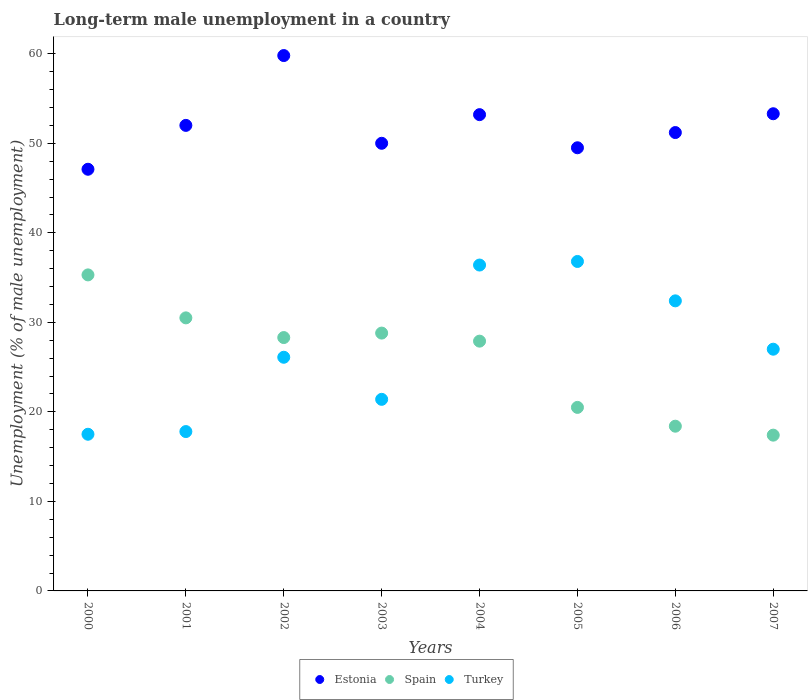Is the number of dotlines equal to the number of legend labels?
Your answer should be very brief. Yes. Across all years, what is the maximum percentage of long-term unemployed male population in Turkey?
Provide a succinct answer. 36.8. Across all years, what is the minimum percentage of long-term unemployed male population in Spain?
Keep it short and to the point. 17.4. What is the total percentage of long-term unemployed male population in Spain in the graph?
Offer a terse response. 207.1. What is the difference between the percentage of long-term unemployed male population in Estonia in 2002 and that in 2004?
Provide a short and direct response. 6.6. What is the difference between the percentage of long-term unemployed male population in Turkey in 2003 and the percentage of long-term unemployed male population in Spain in 2001?
Your answer should be compact. -9.1. What is the average percentage of long-term unemployed male population in Turkey per year?
Provide a succinct answer. 26.93. In the year 2004, what is the difference between the percentage of long-term unemployed male population in Estonia and percentage of long-term unemployed male population in Turkey?
Provide a succinct answer. 16.8. What is the ratio of the percentage of long-term unemployed male population in Turkey in 2002 to that in 2003?
Provide a short and direct response. 1.22. Is the percentage of long-term unemployed male population in Spain in 2000 less than that in 2007?
Your answer should be very brief. No. What is the difference between the highest and the second highest percentage of long-term unemployed male population in Spain?
Provide a short and direct response. 4.8. What is the difference between the highest and the lowest percentage of long-term unemployed male population in Spain?
Your answer should be compact. 17.9. Is the sum of the percentage of long-term unemployed male population in Turkey in 2005 and 2007 greater than the maximum percentage of long-term unemployed male population in Estonia across all years?
Your answer should be compact. Yes. Is the percentage of long-term unemployed male population in Estonia strictly greater than the percentage of long-term unemployed male population in Spain over the years?
Offer a very short reply. Yes. Is the percentage of long-term unemployed male population in Turkey strictly less than the percentage of long-term unemployed male population in Estonia over the years?
Keep it short and to the point. Yes. What is the difference between two consecutive major ticks on the Y-axis?
Make the answer very short. 10. Are the values on the major ticks of Y-axis written in scientific E-notation?
Make the answer very short. No. Does the graph contain grids?
Keep it short and to the point. No. Where does the legend appear in the graph?
Ensure brevity in your answer.  Bottom center. How are the legend labels stacked?
Ensure brevity in your answer.  Horizontal. What is the title of the graph?
Make the answer very short. Long-term male unemployment in a country. Does "Bulgaria" appear as one of the legend labels in the graph?
Your answer should be very brief. No. What is the label or title of the Y-axis?
Offer a terse response. Unemployment (% of male unemployment). What is the Unemployment (% of male unemployment) in Estonia in 2000?
Offer a very short reply. 47.1. What is the Unemployment (% of male unemployment) in Spain in 2000?
Give a very brief answer. 35.3. What is the Unemployment (% of male unemployment) in Estonia in 2001?
Your answer should be compact. 52. What is the Unemployment (% of male unemployment) of Spain in 2001?
Make the answer very short. 30.5. What is the Unemployment (% of male unemployment) in Turkey in 2001?
Ensure brevity in your answer.  17.8. What is the Unemployment (% of male unemployment) of Estonia in 2002?
Make the answer very short. 59.8. What is the Unemployment (% of male unemployment) of Spain in 2002?
Provide a short and direct response. 28.3. What is the Unemployment (% of male unemployment) in Turkey in 2002?
Make the answer very short. 26.1. What is the Unemployment (% of male unemployment) of Spain in 2003?
Ensure brevity in your answer.  28.8. What is the Unemployment (% of male unemployment) of Turkey in 2003?
Your response must be concise. 21.4. What is the Unemployment (% of male unemployment) of Estonia in 2004?
Your answer should be compact. 53.2. What is the Unemployment (% of male unemployment) of Spain in 2004?
Ensure brevity in your answer.  27.9. What is the Unemployment (% of male unemployment) of Turkey in 2004?
Make the answer very short. 36.4. What is the Unemployment (% of male unemployment) of Estonia in 2005?
Offer a very short reply. 49.5. What is the Unemployment (% of male unemployment) in Spain in 2005?
Your answer should be very brief. 20.5. What is the Unemployment (% of male unemployment) of Turkey in 2005?
Offer a terse response. 36.8. What is the Unemployment (% of male unemployment) in Estonia in 2006?
Your answer should be compact. 51.2. What is the Unemployment (% of male unemployment) of Spain in 2006?
Make the answer very short. 18.4. What is the Unemployment (% of male unemployment) in Turkey in 2006?
Give a very brief answer. 32.4. What is the Unemployment (% of male unemployment) in Estonia in 2007?
Your answer should be compact. 53.3. What is the Unemployment (% of male unemployment) of Spain in 2007?
Give a very brief answer. 17.4. What is the Unemployment (% of male unemployment) in Turkey in 2007?
Your answer should be very brief. 27. Across all years, what is the maximum Unemployment (% of male unemployment) of Estonia?
Offer a terse response. 59.8. Across all years, what is the maximum Unemployment (% of male unemployment) in Spain?
Your answer should be compact. 35.3. Across all years, what is the maximum Unemployment (% of male unemployment) in Turkey?
Offer a very short reply. 36.8. Across all years, what is the minimum Unemployment (% of male unemployment) in Estonia?
Your answer should be compact. 47.1. Across all years, what is the minimum Unemployment (% of male unemployment) of Spain?
Offer a very short reply. 17.4. What is the total Unemployment (% of male unemployment) in Estonia in the graph?
Make the answer very short. 416.1. What is the total Unemployment (% of male unemployment) in Spain in the graph?
Offer a terse response. 207.1. What is the total Unemployment (% of male unemployment) in Turkey in the graph?
Offer a very short reply. 215.4. What is the difference between the Unemployment (% of male unemployment) of Spain in 2000 and that in 2001?
Offer a terse response. 4.8. What is the difference between the Unemployment (% of male unemployment) in Spain in 2000 and that in 2002?
Your answer should be compact. 7. What is the difference between the Unemployment (% of male unemployment) of Spain in 2000 and that in 2003?
Your response must be concise. 6.5. What is the difference between the Unemployment (% of male unemployment) of Estonia in 2000 and that in 2004?
Give a very brief answer. -6.1. What is the difference between the Unemployment (% of male unemployment) of Spain in 2000 and that in 2004?
Offer a terse response. 7.4. What is the difference between the Unemployment (% of male unemployment) in Turkey in 2000 and that in 2004?
Make the answer very short. -18.9. What is the difference between the Unemployment (% of male unemployment) in Estonia in 2000 and that in 2005?
Your answer should be compact. -2.4. What is the difference between the Unemployment (% of male unemployment) of Spain in 2000 and that in 2005?
Your answer should be very brief. 14.8. What is the difference between the Unemployment (% of male unemployment) of Turkey in 2000 and that in 2005?
Your response must be concise. -19.3. What is the difference between the Unemployment (% of male unemployment) of Spain in 2000 and that in 2006?
Provide a short and direct response. 16.9. What is the difference between the Unemployment (% of male unemployment) in Turkey in 2000 and that in 2006?
Make the answer very short. -14.9. What is the difference between the Unemployment (% of male unemployment) in Estonia in 2000 and that in 2007?
Ensure brevity in your answer.  -6.2. What is the difference between the Unemployment (% of male unemployment) of Spain in 2000 and that in 2007?
Offer a terse response. 17.9. What is the difference between the Unemployment (% of male unemployment) in Turkey in 2000 and that in 2007?
Provide a succinct answer. -9.5. What is the difference between the Unemployment (% of male unemployment) of Turkey in 2001 and that in 2002?
Provide a short and direct response. -8.3. What is the difference between the Unemployment (% of male unemployment) of Estonia in 2001 and that in 2004?
Give a very brief answer. -1.2. What is the difference between the Unemployment (% of male unemployment) of Turkey in 2001 and that in 2004?
Give a very brief answer. -18.6. What is the difference between the Unemployment (% of male unemployment) in Estonia in 2001 and that in 2005?
Your response must be concise. 2.5. What is the difference between the Unemployment (% of male unemployment) of Turkey in 2001 and that in 2005?
Your answer should be very brief. -19. What is the difference between the Unemployment (% of male unemployment) of Spain in 2001 and that in 2006?
Provide a succinct answer. 12.1. What is the difference between the Unemployment (% of male unemployment) of Turkey in 2001 and that in 2006?
Offer a very short reply. -14.6. What is the difference between the Unemployment (% of male unemployment) in Estonia in 2002 and that in 2003?
Provide a succinct answer. 9.8. What is the difference between the Unemployment (% of male unemployment) of Estonia in 2002 and that in 2005?
Keep it short and to the point. 10.3. What is the difference between the Unemployment (% of male unemployment) of Estonia in 2002 and that in 2006?
Keep it short and to the point. 8.6. What is the difference between the Unemployment (% of male unemployment) of Turkey in 2002 and that in 2006?
Your answer should be very brief. -6.3. What is the difference between the Unemployment (% of male unemployment) of Spain in 2002 and that in 2007?
Offer a very short reply. 10.9. What is the difference between the Unemployment (% of male unemployment) in Turkey in 2002 and that in 2007?
Make the answer very short. -0.9. What is the difference between the Unemployment (% of male unemployment) in Turkey in 2003 and that in 2005?
Make the answer very short. -15.4. What is the difference between the Unemployment (% of male unemployment) in Estonia in 2003 and that in 2006?
Your answer should be compact. -1.2. What is the difference between the Unemployment (% of male unemployment) of Turkey in 2003 and that in 2006?
Your answer should be compact. -11. What is the difference between the Unemployment (% of male unemployment) in Estonia in 2003 and that in 2007?
Provide a short and direct response. -3.3. What is the difference between the Unemployment (% of male unemployment) of Turkey in 2003 and that in 2007?
Your answer should be very brief. -5.6. What is the difference between the Unemployment (% of male unemployment) in Spain in 2004 and that in 2006?
Provide a short and direct response. 9.5. What is the difference between the Unemployment (% of male unemployment) of Turkey in 2004 and that in 2006?
Offer a very short reply. 4. What is the difference between the Unemployment (% of male unemployment) of Turkey in 2004 and that in 2007?
Your response must be concise. 9.4. What is the difference between the Unemployment (% of male unemployment) in Estonia in 2005 and that in 2006?
Your answer should be compact. -1.7. What is the difference between the Unemployment (% of male unemployment) in Spain in 2005 and that in 2006?
Your response must be concise. 2.1. What is the difference between the Unemployment (% of male unemployment) in Turkey in 2005 and that in 2006?
Ensure brevity in your answer.  4.4. What is the difference between the Unemployment (% of male unemployment) in Estonia in 2005 and that in 2007?
Make the answer very short. -3.8. What is the difference between the Unemployment (% of male unemployment) of Spain in 2005 and that in 2007?
Give a very brief answer. 3.1. What is the difference between the Unemployment (% of male unemployment) of Estonia in 2006 and that in 2007?
Provide a succinct answer. -2.1. What is the difference between the Unemployment (% of male unemployment) of Turkey in 2006 and that in 2007?
Offer a terse response. 5.4. What is the difference between the Unemployment (% of male unemployment) in Estonia in 2000 and the Unemployment (% of male unemployment) in Spain in 2001?
Your answer should be compact. 16.6. What is the difference between the Unemployment (% of male unemployment) of Estonia in 2000 and the Unemployment (% of male unemployment) of Turkey in 2001?
Ensure brevity in your answer.  29.3. What is the difference between the Unemployment (% of male unemployment) in Estonia in 2000 and the Unemployment (% of male unemployment) in Spain in 2002?
Provide a short and direct response. 18.8. What is the difference between the Unemployment (% of male unemployment) in Estonia in 2000 and the Unemployment (% of male unemployment) in Turkey in 2002?
Give a very brief answer. 21. What is the difference between the Unemployment (% of male unemployment) in Estonia in 2000 and the Unemployment (% of male unemployment) in Spain in 2003?
Keep it short and to the point. 18.3. What is the difference between the Unemployment (% of male unemployment) in Estonia in 2000 and the Unemployment (% of male unemployment) in Turkey in 2003?
Keep it short and to the point. 25.7. What is the difference between the Unemployment (% of male unemployment) in Estonia in 2000 and the Unemployment (% of male unemployment) in Spain in 2005?
Provide a short and direct response. 26.6. What is the difference between the Unemployment (% of male unemployment) in Estonia in 2000 and the Unemployment (% of male unemployment) in Turkey in 2005?
Offer a very short reply. 10.3. What is the difference between the Unemployment (% of male unemployment) of Spain in 2000 and the Unemployment (% of male unemployment) of Turkey in 2005?
Your answer should be very brief. -1.5. What is the difference between the Unemployment (% of male unemployment) in Estonia in 2000 and the Unemployment (% of male unemployment) in Spain in 2006?
Make the answer very short. 28.7. What is the difference between the Unemployment (% of male unemployment) of Estonia in 2000 and the Unemployment (% of male unemployment) of Turkey in 2006?
Your response must be concise. 14.7. What is the difference between the Unemployment (% of male unemployment) in Estonia in 2000 and the Unemployment (% of male unemployment) in Spain in 2007?
Make the answer very short. 29.7. What is the difference between the Unemployment (% of male unemployment) of Estonia in 2000 and the Unemployment (% of male unemployment) of Turkey in 2007?
Your answer should be very brief. 20.1. What is the difference between the Unemployment (% of male unemployment) of Estonia in 2001 and the Unemployment (% of male unemployment) of Spain in 2002?
Give a very brief answer. 23.7. What is the difference between the Unemployment (% of male unemployment) in Estonia in 2001 and the Unemployment (% of male unemployment) in Turkey in 2002?
Offer a very short reply. 25.9. What is the difference between the Unemployment (% of male unemployment) in Estonia in 2001 and the Unemployment (% of male unemployment) in Spain in 2003?
Provide a succinct answer. 23.2. What is the difference between the Unemployment (% of male unemployment) in Estonia in 2001 and the Unemployment (% of male unemployment) in Turkey in 2003?
Provide a succinct answer. 30.6. What is the difference between the Unemployment (% of male unemployment) of Estonia in 2001 and the Unemployment (% of male unemployment) of Spain in 2004?
Offer a terse response. 24.1. What is the difference between the Unemployment (% of male unemployment) in Estonia in 2001 and the Unemployment (% of male unemployment) in Turkey in 2004?
Offer a terse response. 15.6. What is the difference between the Unemployment (% of male unemployment) of Estonia in 2001 and the Unemployment (% of male unemployment) of Spain in 2005?
Offer a very short reply. 31.5. What is the difference between the Unemployment (% of male unemployment) of Estonia in 2001 and the Unemployment (% of male unemployment) of Turkey in 2005?
Ensure brevity in your answer.  15.2. What is the difference between the Unemployment (% of male unemployment) in Spain in 2001 and the Unemployment (% of male unemployment) in Turkey in 2005?
Provide a succinct answer. -6.3. What is the difference between the Unemployment (% of male unemployment) of Estonia in 2001 and the Unemployment (% of male unemployment) of Spain in 2006?
Give a very brief answer. 33.6. What is the difference between the Unemployment (% of male unemployment) of Estonia in 2001 and the Unemployment (% of male unemployment) of Turkey in 2006?
Give a very brief answer. 19.6. What is the difference between the Unemployment (% of male unemployment) in Spain in 2001 and the Unemployment (% of male unemployment) in Turkey in 2006?
Provide a short and direct response. -1.9. What is the difference between the Unemployment (% of male unemployment) of Estonia in 2001 and the Unemployment (% of male unemployment) of Spain in 2007?
Keep it short and to the point. 34.6. What is the difference between the Unemployment (% of male unemployment) of Spain in 2001 and the Unemployment (% of male unemployment) of Turkey in 2007?
Keep it short and to the point. 3.5. What is the difference between the Unemployment (% of male unemployment) of Estonia in 2002 and the Unemployment (% of male unemployment) of Spain in 2003?
Provide a short and direct response. 31. What is the difference between the Unemployment (% of male unemployment) in Estonia in 2002 and the Unemployment (% of male unemployment) in Turkey in 2003?
Make the answer very short. 38.4. What is the difference between the Unemployment (% of male unemployment) of Spain in 2002 and the Unemployment (% of male unemployment) of Turkey in 2003?
Offer a very short reply. 6.9. What is the difference between the Unemployment (% of male unemployment) of Estonia in 2002 and the Unemployment (% of male unemployment) of Spain in 2004?
Make the answer very short. 31.9. What is the difference between the Unemployment (% of male unemployment) in Estonia in 2002 and the Unemployment (% of male unemployment) in Turkey in 2004?
Offer a terse response. 23.4. What is the difference between the Unemployment (% of male unemployment) in Spain in 2002 and the Unemployment (% of male unemployment) in Turkey in 2004?
Make the answer very short. -8.1. What is the difference between the Unemployment (% of male unemployment) in Estonia in 2002 and the Unemployment (% of male unemployment) in Spain in 2005?
Make the answer very short. 39.3. What is the difference between the Unemployment (% of male unemployment) of Estonia in 2002 and the Unemployment (% of male unemployment) of Turkey in 2005?
Offer a terse response. 23. What is the difference between the Unemployment (% of male unemployment) of Estonia in 2002 and the Unemployment (% of male unemployment) of Spain in 2006?
Your response must be concise. 41.4. What is the difference between the Unemployment (% of male unemployment) of Estonia in 2002 and the Unemployment (% of male unemployment) of Turkey in 2006?
Provide a succinct answer. 27.4. What is the difference between the Unemployment (% of male unemployment) of Estonia in 2002 and the Unemployment (% of male unemployment) of Spain in 2007?
Give a very brief answer. 42.4. What is the difference between the Unemployment (% of male unemployment) in Estonia in 2002 and the Unemployment (% of male unemployment) in Turkey in 2007?
Provide a short and direct response. 32.8. What is the difference between the Unemployment (% of male unemployment) in Estonia in 2003 and the Unemployment (% of male unemployment) in Spain in 2004?
Make the answer very short. 22.1. What is the difference between the Unemployment (% of male unemployment) of Estonia in 2003 and the Unemployment (% of male unemployment) of Turkey in 2004?
Your answer should be very brief. 13.6. What is the difference between the Unemployment (% of male unemployment) of Spain in 2003 and the Unemployment (% of male unemployment) of Turkey in 2004?
Provide a short and direct response. -7.6. What is the difference between the Unemployment (% of male unemployment) in Estonia in 2003 and the Unemployment (% of male unemployment) in Spain in 2005?
Your response must be concise. 29.5. What is the difference between the Unemployment (% of male unemployment) of Estonia in 2003 and the Unemployment (% of male unemployment) of Turkey in 2005?
Provide a succinct answer. 13.2. What is the difference between the Unemployment (% of male unemployment) of Estonia in 2003 and the Unemployment (% of male unemployment) of Spain in 2006?
Keep it short and to the point. 31.6. What is the difference between the Unemployment (% of male unemployment) of Spain in 2003 and the Unemployment (% of male unemployment) of Turkey in 2006?
Ensure brevity in your answer.  -3.6. What is the difference between the Unemployment (% of male unemployment) in Estonia in 2003 and the Unemployment (% of male unemployment) in Spain in 2007?
Ensure brevity in your answer.  32.6. What is the difference between the Unemployment (% of male unemployment) in Spain in 2003 and the Unemployment (% of male unemployment) in Turkey in 2007?
Make the answer very short. 1.8. What is the difference between the Unemployment (% of male unemployment) in Estonia in 2004 and the Unemployment (% of male unemployment) in Spain in 2005?
Your answer should be compact. 32.7. What is the difference between the Unemployment (% of male unemployment) of Estonia in 2004 and the Unemployment (% of male unemployment) of Turkey in 2005?
Your answer should be compact. 16.4. What is the difference between the Unemployment (% of male unemployment) of Spain in 2004 and the Unemployment (% of male unemployment) of Turkey in 2005?
Give a very brief answer. -8.9. What is the difference between the Unemployment (% of male unemployment) of Estonia in 2004 and the Unemployment (% of male unemployment) of Spain in 2006?
Make the answer very short. 34.8. What is the difference between the Unemployment (% of male unemployment) in Estonia in 2004 and the Unemployment (% of male unemployment) in Turkey in 2006?
Your response must be concise. 20.8. What is the difference between the Unemployment (% of male unemployment) in Spain in 2004 and the Unemployment (% of male unemployment) in Turkey in 2006?
Keep it short and to the point. -4.5. What is the difference between the Unemployment (% of male unemployment) of Estonia in 2004 and the Unemployment (% of male unemployment) of Spain in 2007?
Give a very brief answer. 35.8. What is the difference between the Unemployment (% of male unemployment) of Estonia in 2004 and the Unemployment (% of male unemployment) of Turkey in 2007?
Offer a very short reply. 26.2. What is the difference between the Unemployment (% of male unemployment) of Spain in 2004 and the Unemployment (% of male unemployment) of Turkey in 2007?
Give a very brief answer. 0.9. What is the difference between the Unemployment (% of male unemployment) of Estonia in 2005 and the Unemployment (% of male unemployment) of Spain in 2006?
Your answer should be very brief. 31.1. What is the difference between the Unemployment (% of male unemployment) of Estonia in 2005 and the Unemployment (% of male unemployment) of Spain in 2007?
Your answer should be compact. 32.1. What is the difference between the Unemployment (% of male unemployment) of Estonia in 2005 and the Unemployment (% of male unemployment) of Turkey in 2007?
Ensure brevity in your answer.  22.5. What is the difference between the Unemployment (% of male unemployment) of Spain in 2005 and the Unemployment (% of male unemployment) of Turkey in 2007?
Ensure brevity in your answer.  -6.5. What is the difference between the Unemployment (% of male unemployment) in Estonia in 2006 and the Unemployment (% of male unemployment) in Spain in 2007?
Offer a very short reply. 33.8. What is the difference between the Unemployment (% of male unemployment) of Estonia in 2006 and the Unemployment (% of male unemployment) of Turkey in 2007?
Provide a succinct answer. 24.2. What is the average Unemployment (% of male unemployment) in Estonia per year?
Give a very brief answer. 52.01. What is the average Unemployment (% of male unemployment) in Spain per year?
Give a very brief answer. 25.89. What is the average Unemployment (% of male unemployment) of Turkey per year?
Make the answer very short. 26.93. In the year 2000, what is the difference between the Unemployment (% of male unemployment) of Estonia and Unemployment (% of male unemployment) of Spain?
Your answer should be compact. 11.8. In the year 2000, what is the difference between the Unemployment (% of male unemployment) in Estonia and Unemployment (% of male unemployment) in Turkey?
Ensure brevity in your answer.  29.6. In the year 2001, what is the difference between the Unemployment (% of male unemployment) of Estonia and Unemployment (% of male unemployment) of Spain?
Your response must be concise. 21.5. In the year 2001, what is the difference between the Unemployment (% of male unemployment) of Estonia and Unemployment (% of male unemployment) of Turkey?
Keep it short and to the point. 34.2. In the year 2001, what is the difference between the Unemployment (% of male unemployment) in Spain and Unemployment (% of male unemployment) in Turkey?
Your answer should be very brief. 12.7. In the year 2002, what is the difference between the Unemployment (% of male unemployment) of Estonia and Unemployment (% of male unemployment) of Spain?
Your response must be concise. 31.5. In the year 2002, what is the difference between the Unemployment (% of male unemployment) in Estonia and Unemployment (% of male unemployment) in Turkey?
Your answer should be compact. 33.7. In the year 2002, what is the difference between the Unemployment (% of male unemployment) of Spain and Unemployment (% of male unemployment) of Turkey?
Keep it short and to the point. 2.2. In the year 2003, what is the difference between the Unemployment (% of male unemployment) in Estonia and Unemployment (% of male unemployment) in Spain?
Offer a terse response. 21.2. In the year 2003, what is the difference between the Unemployment (% of male unemployment) in Estonia and Unemployment (% of male unemployment) in Turkey?
Your response must be concise. 28.6. In the year 2004, what is the difference between the Unemployment (% of male unemployment) of Estonia and Unemployment (% of male unemployment) of Spain?
Your answer should be very brief. 25.3. In the year 2005, what is the difference between the Unemployment (% of male unemployment) of Estonia and Unemployment (% of male unemployment) of Turkey?
Provide a short and direct response. 12.7. In the year 2005, what is the difference between the Unemployment (% of male unemployment) of Spain and Unemployment (% of male unemployment) of Turkey?
Keep it short and to the point. -16.3. In the year 2006, what is the difference between the Unemployment (% of male unemployment) in Estonia and Unemployment (% of male unemployment) in Spain?
Offer a terse response. 32.8. In the year 2007, what is the difference between the Unemployment (% of male unemployment) of Estonia and Unemployment (% of male unemployment) of Spain?
Make the answer very short. 35.9. In the year 2007, what is the difference between the Unemployment (% of male unemployment) of Estonia and Unemployment (% of male unemployment) of Turkey?
Offer a very short reply. 26.3. In the year 2007, what is the difference between the Unemployment (% of male unemployment) in Spain and Unemployment (% of male unemployment) in Turkey?
Provide a short and direct response. -9.6. What is the ratio of the Unemployment (% of male unemployment) of Estonia in 2000 to that in 2001?
Provide a succinct answer. 0.91. What is the ratio of the Unemployment (% of male unemployment) of Spain in 2000 to that in 2001?
Offer a very short reply. 1.16. What is the ratio of the Unemployment (% of male unemployment) of Turkey in 2000 to that in 2001?
Provide a succinct answer. 0.98. What is the ratio of the Unemployment (% of male unemployment) of Estonia in 2000 to that in 2002?
Provide a short and direct response. 0.79. What is the ratio of the Unemployment (% of male unemployment) of Spain in 2000 to that in 2002?
Your answer should be compact. 1.25. What is the ratio of the Unemployment (% of male unemployment) of Turkey in 2000 to that in 2002?
Make the answer very short. 0.67. What is the ratio of the Unemployment (% of male unemployment) in Estonia in 2000 to that in 2003?
Your answer should be compact. 0.94. What is the ratio of the Unemployment (% of male unemployment) in Spain in 2000 to that in 2003?
Your answer should be very brief. 1.23. What is the ratio of the Unemployment (% of male unemployment) in Turkey in 2000 to that in 2003?
Give a very brief answer. 0.82. What is the ratio of the Unemployment (% of male unemployment) of Estonia in 2000 to that in 2004?
Keep it short and to the point. 0.89. What is the ratio of the Unemployment (% of male unemployment) of Spain in 2000 to that in 2004?
Keep it short and to the point. 1.27. What is the ratio of the Unemployment (% of male unemployment) of Turkey in 2000 to that in 2004?
Keep it short and to the point. 0.48. What is the ratio of the Unemployment (% of male unemployment) of Estonia in 2000 to that in 2005?
Provide a succinct answer. 0.95. What is the ratio of the Unemployment (% of male unemployment) of Spain in 2000 to that in 2005?
Your answer should be compact. 1.72. What is the ratio of the Unemployment (% of male unemployment) in Turkey in 2000 to that in 2005?
Your answer should be very brief. 0.48. What is the ratio of the Unemployment (% of male unemployment) of Estonia in 2000 to that in 2006?
Give a very brief answer. 0.92. What is the ratio of the Unemployment (% of male unemployment) in Spain in 2000 to that in 2006?
Provide a succinct answer. 1.92. What is the ratio of the Unemployment (% of male unemployment) in Turkey in 2000 to that in 2006?
Keep it short and to the point. 0.54. What is the ratio of the Unemployment (% of male unemployment) of Estonia in 2000 to that in 2007?
Keep it short and to the point. 0.88. What is the ratio of the Unemployment (% of male unemployment) in Spain in 2000 to that in 2007?
Your answer should be compact. 2.03. What is the ratio of the Unemployment (% of male unemployment) of Turkey in 2000 to that in 2007?
Offer a very short reply. 0.65. What is the ratio of the Unemployment (% of male unemployment) in Estonia in 2001 to that in 2002?
Offer a very short reply. 0.87. What is the ratio of the Unemployment (% of male unemployment) in Spain in 2001 to that in 2002?
Provide a succinct answer. 1.08. What is the ratio of the Unemployment (% of male unemployment) of Turkey in 2001 to that in 2002?
Offer a terse response. 0.68. What is the ratio of the Unemployment (% of male unemployment) in Spain in 2001 to that in 2003?
Offer a very short reply. 1.06. What is the ratio of the Unemployment (% of male unemployment) in Turkey in 2001 to that in 2003?
Provide a short and direct response. 0.83. What is the ratio of the Unemployment (% of male unemployment) in Estonia in 2001 to that in 2004?
Offer a very short reply. 0.98. What is the ratio of the Unemployment (% of male unemployment) in Spain in 2001 to that in 2004?
Make the answer very short. 1.09. What is the ratio of the Unemployment (% of male unemployment) in Turkey in 2001 to that in 2004?
Ensure brevity in your answer.  0.49. What is the ratio of the Unemployment (% of male unemployment) of Estonia in 2001 to that in 2005?
Your answer should be compact. 1.05. What is the ratio of the Unemployment (% of male unemployment) in Spain in 2001 to that in 2005?
Give a very brief answer. 1.49. What is the ratio of the Unemployment (% of male unemployment) of Turkey in 2001 to that in 2005?
Give a very brief answer. 0.48. What is the ratio of the Unemployment (% of male unemployment) in Estonia in 2001 to that in 2006?
Provide a short and direct response. 1.02. What is the ratio of the Unemployment (% of male unemployment) in Spain in 2001 to that in 2006?
Offer a terse response. 1.66. What is the ratio of the Unemployment (% of male unemployment) in Turkey in 2001 to that in 2006?
Your response must be concise. 0.55. What is the ratio of the Unemployment (% of male unemployment) in Estonia in 2001 to that in 2007?
Give a very brief answer. 0.98. What is the ratio of the Unemployment (% of male unemployment) in Spain in 2001 to that in 2007?
Make the answer very short. 1.75. What is the ratio of the Unemployment (% of male unemployment) of Turkey in 2001 to that in 2007?
Offer a very short reply. 0.66. What is the ratio of the Unemployment (% of male unemployment) of Estonia in 2002 to that in 2003?
Provide a short and direct response. 1.2. What is the ratio of the Unemployment (% of male unemployment) of Spain in 2002 to that in 2003?
Ensure brevity in your answer.  0.98. What is the ratio of the Unemployment (% of male unemployment) of Turkey in 2002 to that in 2003?
Provide a succinct answer. 1.22. What is the ratio of the Unemployment (% of male unemployment) of Estonia in 2002 to that in 2004?
Keep it short and to the point. 1.12. What is the ratio of the Unemployment (% of male unemployment) in Spain in 2002 to that in 2004?
Offer a terse response. 1.01. What is the ratio of the Unemployment (% of male unemployment) in Turkey in 2002 to that in 2004?
Provide a succinct answer. 0.72. What is the ratio of the Unemployment (% of male unemployment) of Estonia in 2002 to that in 2005?
Your response must be concise. 1.21. What is the ratio of the Unemployment (% of male unemployment) in Spain in 2002 to that in 2005?
Give a very brief answer. 1.38. What is the ratio of the Unemployment (% of male unemployment) in Turkey in 2002 to that in 2005?
Offer a terse response. 0.71. What is the ratio of the Unemployment (% of male unemployment) of Estonia in 2002 to that in 2006?
Provide a succinct answer. 1.17. What is the ratio of the Unemployment (% of male unemployment) of Spain in 2002 to that in 2006?
Offer a very short reply. 1.54. What is the ratio of the Unemployment (% of male unemployment) of Turkey in 2002 to that in 2006?
Your answer should be compact. 0.81. What is the ratio of the Unemployment (% of male unemployment) in Estonia in 2002 to that in 2007?
Provide a succinct answer. 1.12. What is the ratio of the Unemployment (% of male unemployment) of Spain in 2002 to that in 2007?
Your answer should be compact. 1.63. What is the ratio of the Unemployment (% of male unemployment) in Turkey in 2002 to that in 2007?
Ensure brevity in your answer.  0.97. What is the ratio of the Unemployment (% of male unemployment) of Estonia in 2003 to that in 2004?
Provide a short and direct response. 0.94. What is the ratio of the Unemployment (% of male unemployment) in Spain in 2003 to that in 2004?
Offer a terse response. 1.03. What is the ratio of the Unemployment (% of male unemployment) of Turkey in 2003 to that in 2004?
Ensure brevity in your answer.  0.59. What is the ratio of the Unemployment (% of male unemployment) of Spain in 2003 to that in 2005?
Offer a terse response. 1.4. What is the ratio of the Unemployment (% of male unemployment) of Turkey in 2003 to that in 2005?
Your answer should be very brief. 0.58. What is the ratio of the Unemployment (% of male unemployment) of Estonia in 2003 to that in 2006?
Offer a very short reply. 0.98. What is the ratio of the Unemployment (% of male unemployment) of Spain in 2003 to that in 2006?
Make the answer very short. 1.57. What is the ratio of the Unemployment (% of male unemployment) in Turkey in 2003 to that in 2006?
Your response must be concise. 0.66. What is the ratio of the Unemployment (% of male unemployment) of Estonia in 2003 to that in 2007?
Provide a short and direct response. 0.94. What is the ratio of the Unemployment (% of male unemployment) of Spain in 2003 to that in 2007?
Keep it short and to the point. 1.66. What is the ratio of the Unemployment (% of male unemployment) in Turkey in 2003 to that in 2007?
Offer a very short reply. 0.79. What is the ratio of the Unemployment (% of male unemployment) of Estonia in 2004 to that in 2005?
Your answer should be very brief. 1.07. What is the ratio of the Unemployment (% of male unemployment) in Spain in 2004 to that in 2005?
Make the answer very short. 1.36. What is the ratio of the Unemployment (% of male unemployment) in Turkey in 2004 to that in 2005?
Provide a succinct answer. 0.99. What is the ratio of the Unemployment (% of male unemployment) of Estonia in 2004 to that in 2006?
Offer a very short reply. 1.04. What is the ratio of the Unemployment (% of male unemployment) of Spain in 2004 to that in 2006?
Offer a very short reply. 1.52. What is the ratio of the Unemployment (% of male unemployment) of Turkey in 2004 to that in 2006?
Make the answer very short. 1.12. What is the ratio of the Unemployment (% of male unemployment) in Estonia in 2004 to that in 2007?
Your answer should be compact. 1. What is the ratio of the Unemployment (% of male unemployment) of Spain in 2004 to that in 2007?
Keep it short and to the point. 1.6. What is the ratio of the Unemployment (% of male unemployment) in Turkey in 2004 to that in 2007?
Make the answer very short. 1.35. What is the ratio of the Unemployment (% of male unemployment) in Estonia in 2005 to that in 2006?
Your answer should be very brief. 0.97. What is the ratio of the Unemployment (% of male unemployment) of Spain in 2005 to that in 2006?
Keep it short and to the point. 1.11. What is the ratio of the Unemployment (% of male unemployment) in Turkey in 2005 to that in 2006?
Your response must be concise. 1.14. What is the ratio of the Unemployment (% of male unemployment) in Estonia in 2005 to that in 2007?
Provide a succinct answer. 0.93. What is the ratio of the Unemployment (% of male unemployment) of Spain in 2005 to that in 2007?
Offer a terse response. 1.18. What is the ratio of the Unemployment (% of male unemployment) in Turkey in 2005 to that in 2007?
Ensure brevity in your answer.  1.36. What is the ratio of the Unemployment (% of male unemployment) of Estonia in 2006 to that in 2007?
Offer a very short reply. 0.96. What is the ratio of the Unemployment (% of male unemployment) of Spain in 2006 to that in 2007?
Your answer should be very brief. 1.06. What is the difference between the highest and the second highest Unemployment (% of male unemployment) in Estonia?
Give a very brief answer. 6.5. What is the difference between the highest and the second highest Unemployment (% of male unemployment) in Spain?
Offer a very short reply. 4.8. What is the difference between the highest and the second highest Unemployment (% of male unemployment) of Turkey?
Your response must be concise. 0.4. What is the difference between the highest and the lowest Unemployment (% of male unemployment) in Spain?
Provide a succinct answer. 17.9. What is the difference between the highest and the lowest Unemployment (% of male unemployment) of Turkey?
Your answer should be compact. 19.3. 